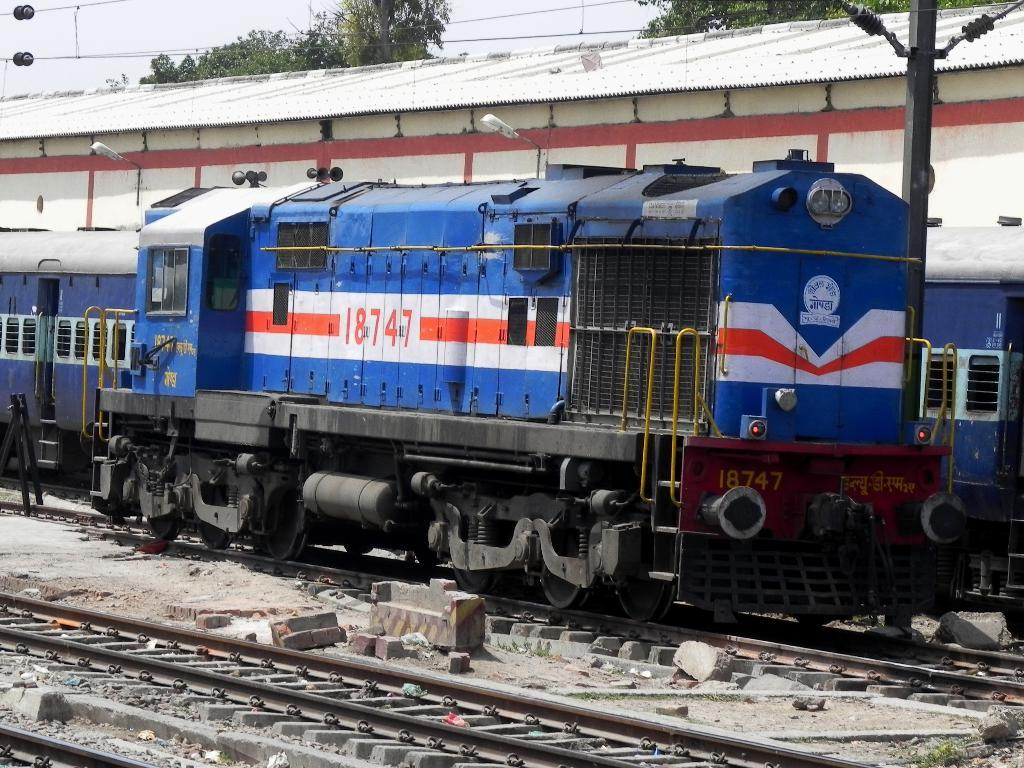What can be seen on the railway tracks in the image? There are trains on the railway tracks in the image. What type of structure is present in the image? There is a shed in the image. What can be seen illuminating the area in the image? There are lights in the image. What are the poles used for in the image? The poles are used to support cables in the image. What are the cables used for in the image? The cables are used for transmitting electricity or communication signals in the image. What type of vegetation is present in the image? There are trees in the image. What type of material is present in the image? There are bricks in the image. What is visible in the background of the image? The sky is visible in the background of the image. What type of cushion is used to support the trains in the image? There is no cushion present in the image; the trains are running on railway tracks. How does the wind affect the movement of the trains in the image? The image does not show any wind, and there is no indication that the wind affects the movement of the trains. 